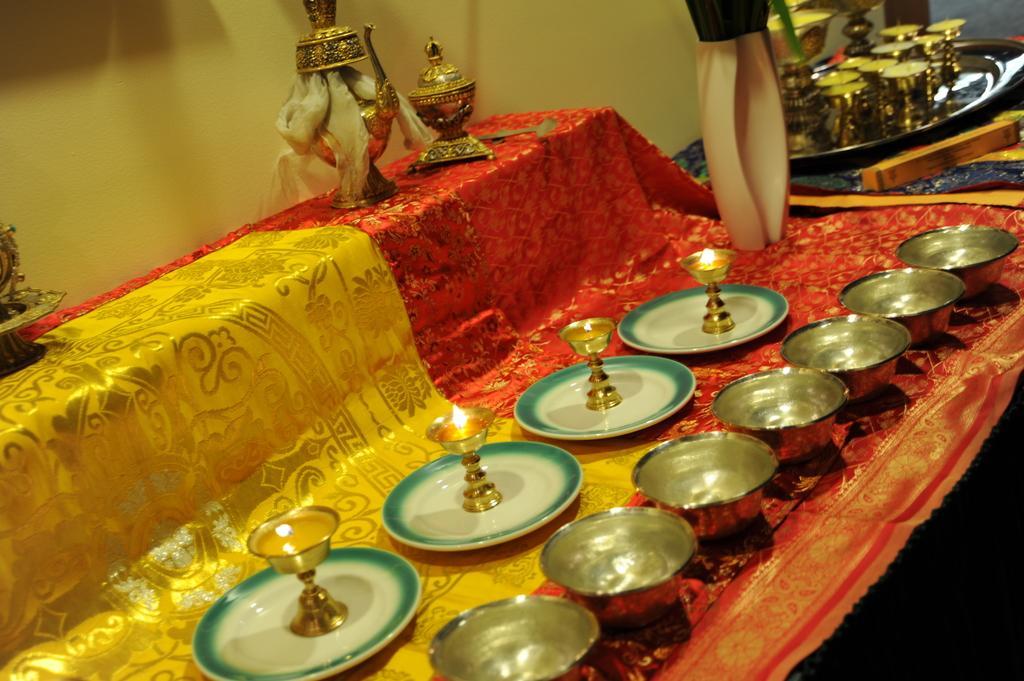Describe this image in one or two sentences. This image is taken indoors. In the background there is a wall. In the middle of the image there is a table with a tablecloth, a few objects, bowls, plates and lamps on it. At the top right of the image there is a tray with many lamps on the table. 